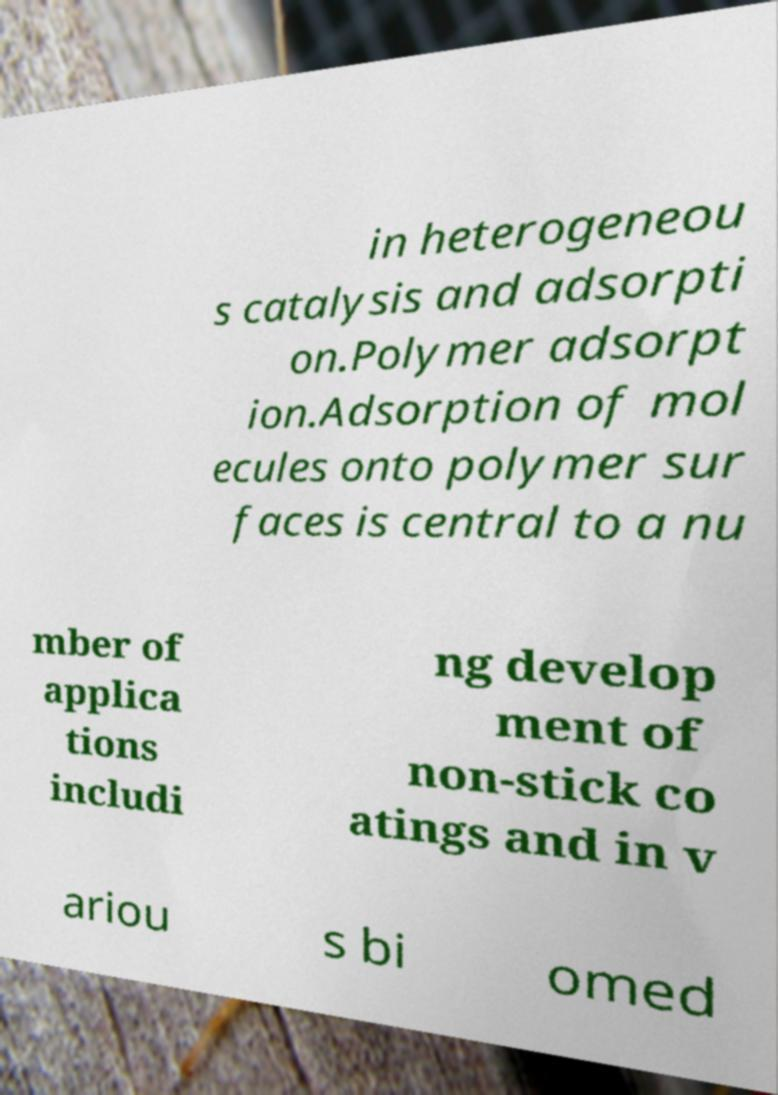I need the written content from this picture converted into text. Can you do that? in heterogeneou s catalysis and adsorpti on.Polymer adsorpt ion.Adsorption of mol ecules onto polymer sur faces is central to a nu mber of applica tions includi ng develop ment of non-stick co atings and in v ariou s bi omed 